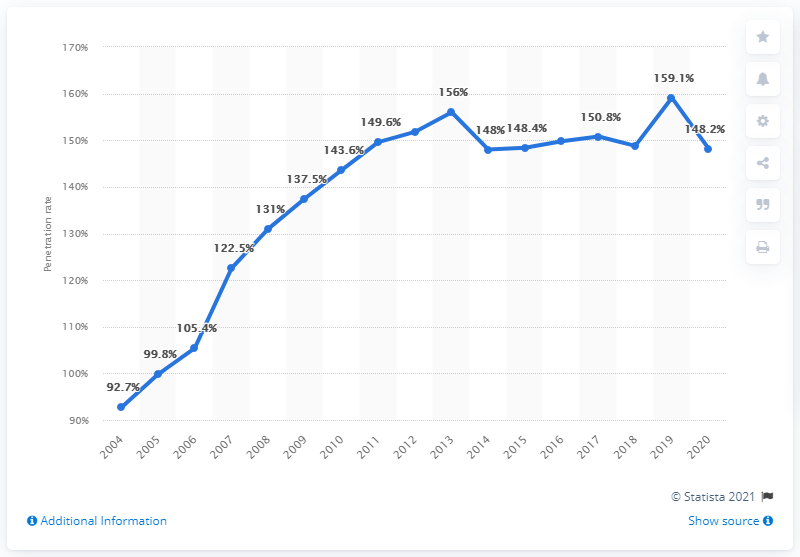Highlight a few significant elements in this photo. In 2020, the mobile phone penetration rate in Singapore was 148.2%. 